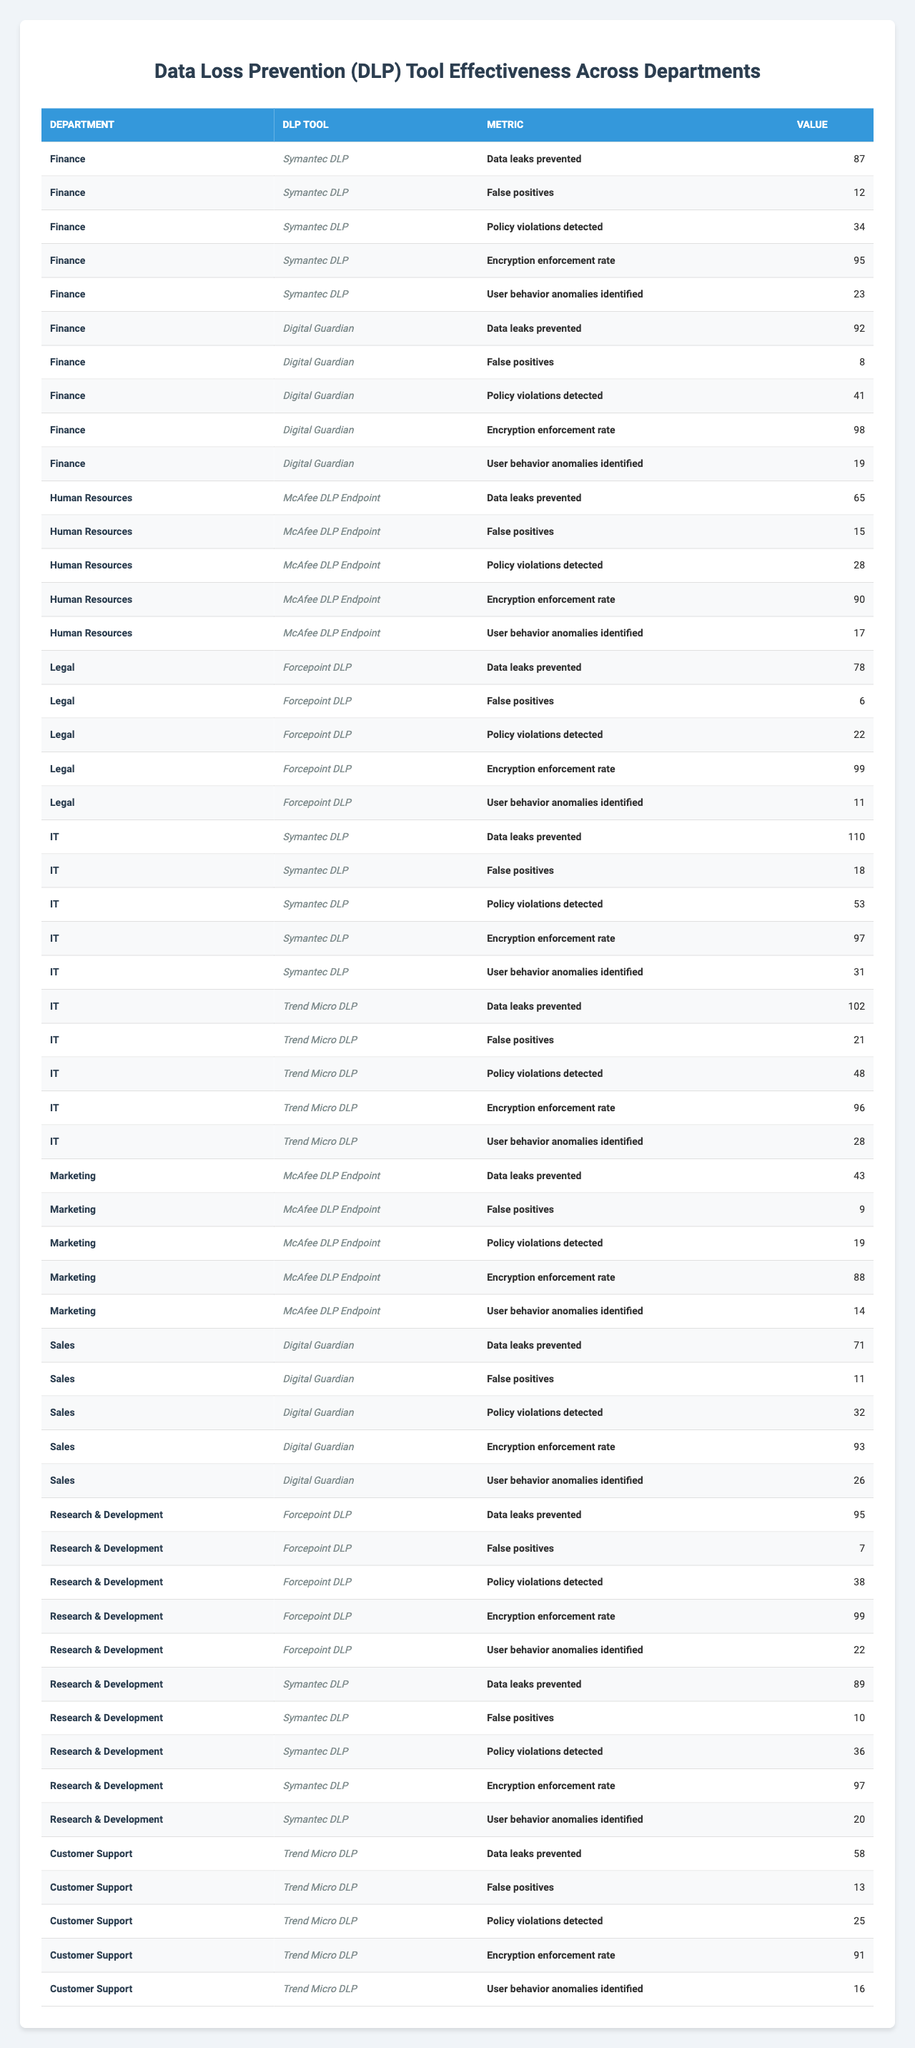What is the highest encryption enforcement rate among the DLP tools in the Finance department? In the Finance department, there are two DLP tools listed: Symantec DLP and Digital Guardian. The encryption enforcement rates are 95% for Symantec DLP and 98% for Digital Guardian. The highest value is 98%.
Answer: 98% Which department has the most DLP tools utilized? The departments with multiple DLP tools are Finance, IT, and Research & Development. Finance has 2 tools (Symantec DLP, Digital Guardian), IT has 2 tools (Symantec DLP, Trend Micro DLP), and Research & Development has 2 tools (Forcepoint DLP, Symantec DLP). Each department has an equal number of tools, making them tied for the highest count.
Answer: Finance, IT, and Research & Development (each with 2 tools) How many total data leaks were prevented in the IT department by both DLP tools? The IT department uses two DLP tools: Symantec DLP, which prevented 110 data leaks, and Trend Micro DLP, which prevented 102 data leaks. Summing these gives 110 + 102 = 212.
Answer: 212 Is there a DLP tool that has a higher false positive count than any others in the Customer Support department? The only DLP tool listed for Customer Support is Trend Micro DLP with a false positive count of 13. Since it's the only tool, the question yields no comparison. Thus, the answer is no, as it has no other tool for comparison within this department.
Answer: No What is the average number of false positives across all departments for the DLP tools listed? The false positive counts are: 12 (Finance, Symantec DLP), 8 (Finance, Digital Guardian), 15 (HR, McAfee DLP), 6 (Legal, Forcepoint DLP), 18 (IT, Symantec DLP), 21 (IT, Trend Micro DLP), 9 (Marketing, McAfee DLP), 11 (Sales, Digital Guardian), 7 (R&D, Forcepoint DLP), 10 (R&D, Symantec DLP), and 13 (Customer Support, Trend Micro DLP). The sum of these counts is 12 + 8 + 15 + 6 + 18 + 21 + 9 + 11 + 7 + 10 + 13 =  140. There are 11 data points, so the average is 140/11 = 12.727.
Answer: Approximately 12.73 Which DLP tool in the Research & Development department had the least policy violations detected? In the Research & Development department, the two DLP tools listed are Forcepoint DLP with 38 policy violations and Symantec DLP with 36 policy violations. Since 36 is less than 38, Symantec DLP had the least policy violations.
Answer: Symantec DLP How many more user behavior anomalies were identified by the IT department's tools than the Marketing department's tool? In the IT department, the user behavior anomalies identified were 31 (Symantec DLP) and 28 (Trend Micro DLP), summing to 59. The Marketing department had 14 identified by McAfee DLP. Therefore, the difference is 59 - 14 = 45, indicating that IT identified 45 more anomalies.
Answer: 45 Which department has the highest total number of data leaks prevented? The number of data leaks prevented by each department's DLP tools is as follows: Finance (Symantec DLP 87 + Digital Guardian 92 = 179), HR (McAfee 65 = 65), Legal (Forcepoint 78 = 78), IT (Symantec DLP 110 + Trend Micro DLP 102 = 212), Marketing (McAfee 43 = 43), Sales (Digital Guardian 71 = 71), R&D (Forcepoint 95 + Symantec DLP 89 = 184), and Customer Support (Trend Micro 58 = 58). The highest total is 212 in the IT department.
Answer: IT department What is the rate of policy violations detected in the Sales department by the Digital Guardian tool? The only DLP tool listed for the Sales department is Digital Guardian, which detected 32 policy violations. Therefore, the rate of policy violations detected is exactly that value.
Answer: 32 Is the encryption enforcement rate for McAfee DLP in Marketing lower than 90%? The encryption enforcement rate for McAfee DLP in Marketing is 88%, which is lower than 90%. Thus, the answer is yes.
Answer: Yes 